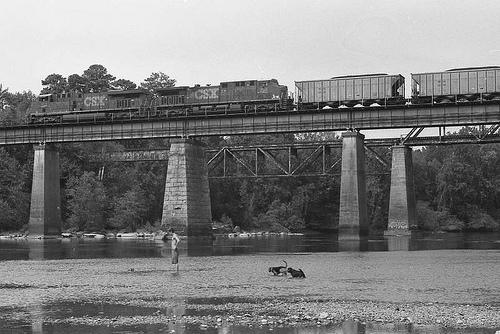Provide a brief and general overview of the image.  A boy with his two dogs, standing in the water near a railway bridge with a CSX train crossing, pillars supporting the bridge, and a black-and-white landscape. Mention the key components of the scene and briefly describe their interactions. A young man with his dogs interacts with water under a railway bridge, as a CSX train passes by on tracks above, held up by tall stone pillars. Write a short description of the scene, focusing on the main elements in the image. A shirtless boy and his two dogs are in the water near a railway bridge with large stone pillars, as a CSX train passes by in the background. Describe the setting of the image and which objects are the most prominent. The setting is an outdoor river scene with a railway trestle crossing above: the most prominent objects are the boy, dogs, train, and bridge pillars. Explain what is happening in the foreground and background of the image.  In the foreground, a shirtless boy alongside two dogs is in the water, while in the background, a train is crossing a bridge supported by large pillars. Pick three main elements in the image and briefly describe their appearances and positions. A young boy in shorts stands in the water along with two dogs, a long train moves on tracks high above, and the tracks are supported by massive stone pillars. Mention the prominent objects and their locations in the image. A train is on the tracks above, a boy and two dogs are in water below, and the bridge is held by large stone pillars surrounded by debris. Provide a concise description of the image, including the most distinguished elements. A black-and-white image captures a boy and two dogs in the water beside a railway bridge with large pillars, as a train passes by. Briefly describe what the person in the image is doing and what their surroundings look like.  A young man in just shorts is standing in the water under a railway bridge with his two dogs, while a train crosses the trestle above. Describe the colors and mood of the image. The image is black and white, depicting a peaceful moment: a boy with two dogs standing by the river under a train bridge, surrounded by nature. 